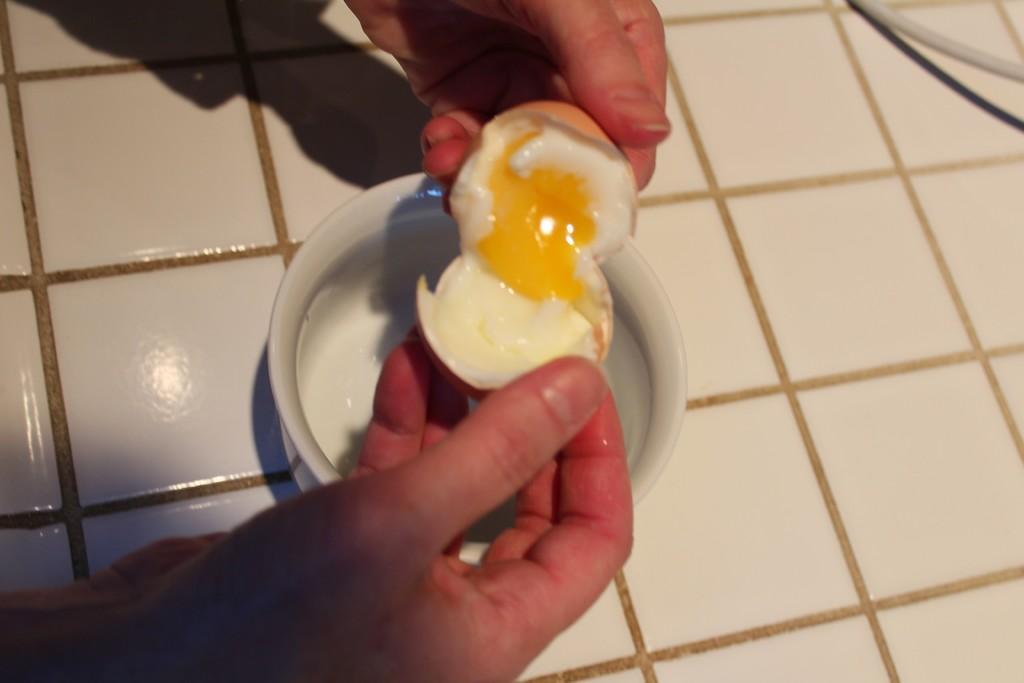How would you summarize this image in a sentence or two? In this image we can see the human hands holding egg. We can see egg yoke. There is marble floor. There is a wire. 